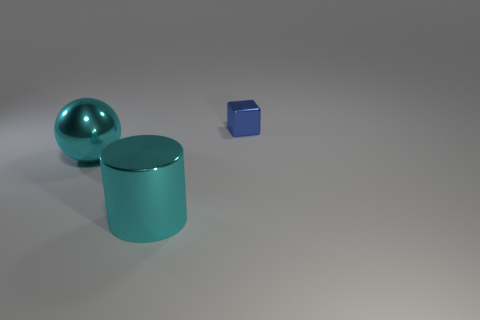Add 1 large green blocks. How many objects exist? 4 Subtract all cylinders. How many objects are left? 2 Subtract all big cyan things. Subtract all big yellow cylinders. How many objects are left? 1 Add 1 tiny blue metallic blocks. How many tiny blue metallic blocks are left? 2 Add 3 tiny blue metal cubes. How many tiny blue metal cubes exist? 4 Subtract 0 green cylinders. How many objects are left? 3 